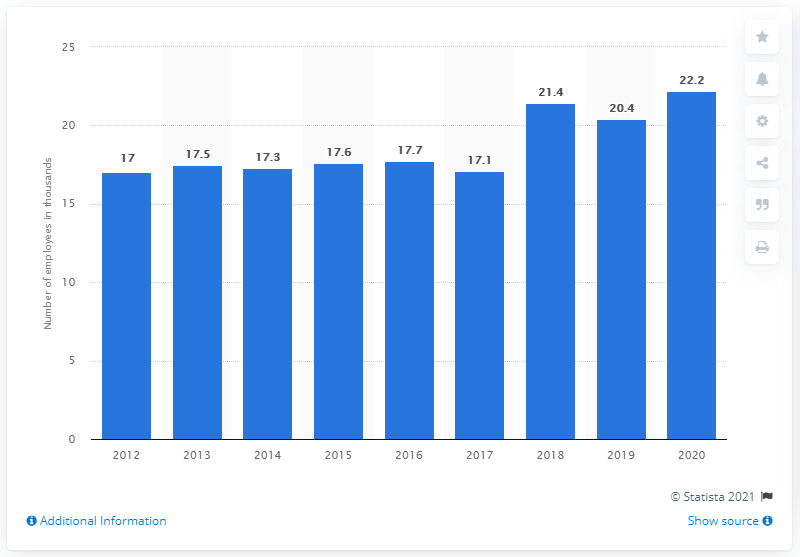Outline some significant characteristics in this image. In 2020, QVC had approximately 22.2 employees. 